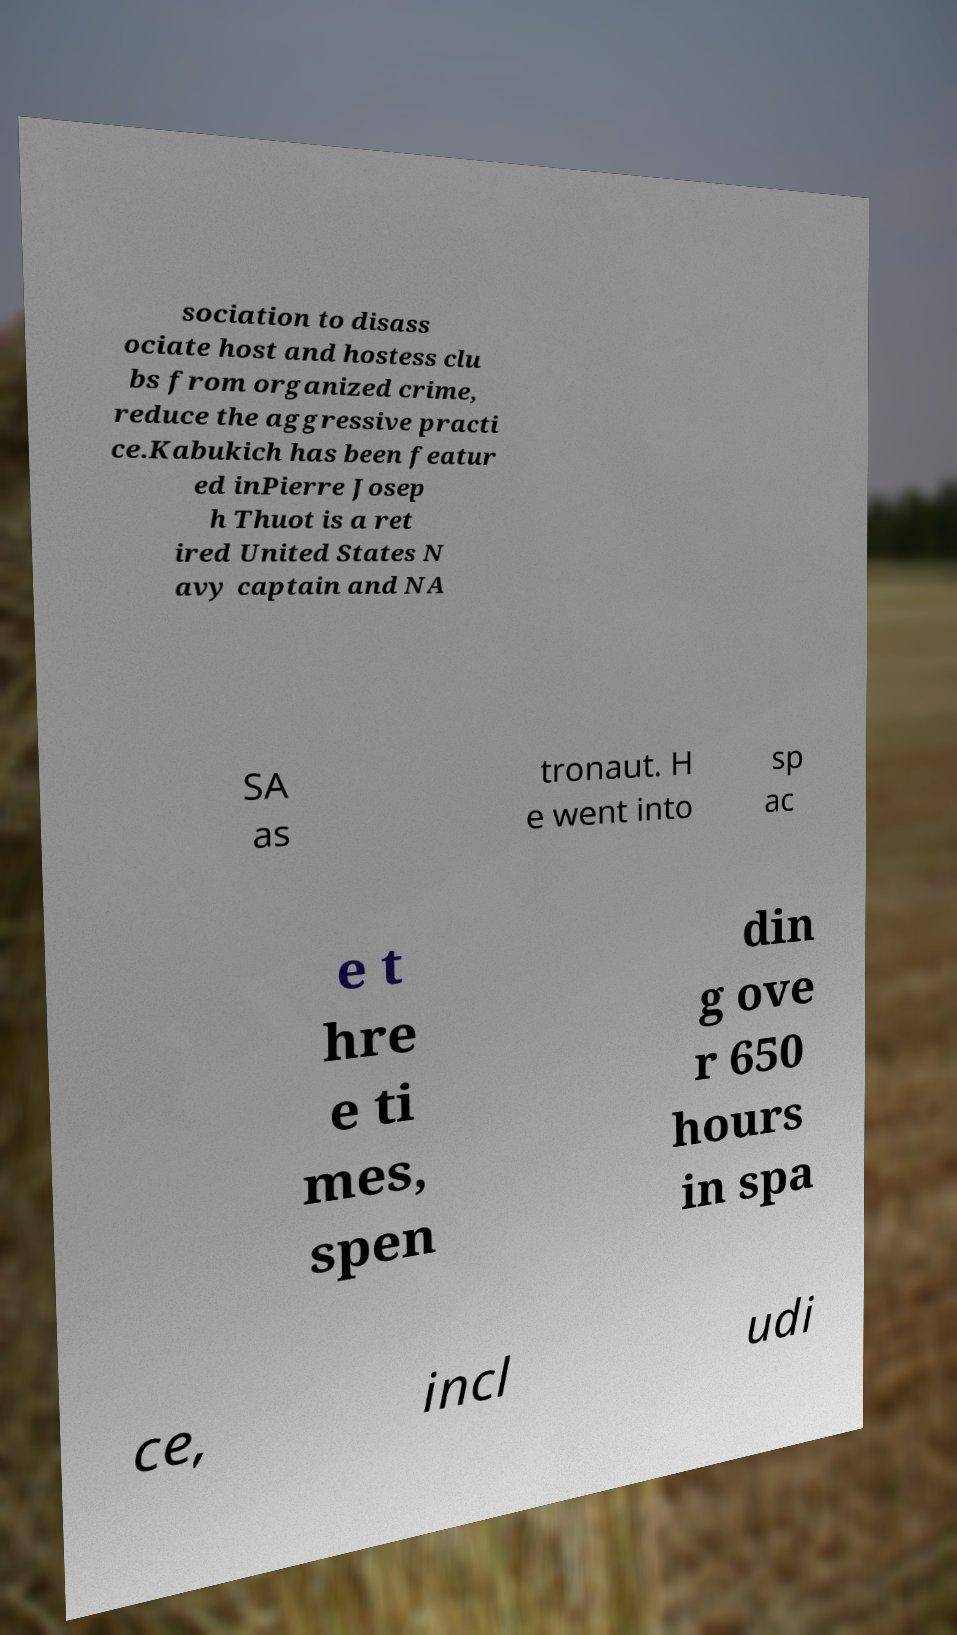For documentation purposes, I need the text within this image transcribed. Could you provide that? sociation to disass ociate host and hostess clu bs from organized crime, reduce the aggressive practi ce.Kabukich has been featur ed inPierre Josep h Thuot is a ret ired United States N avy captain and NA SA as tronaut. H e went into sp ac e t hre e ti mes, spen din g ove r 650 hours in spa ce, incl udi 